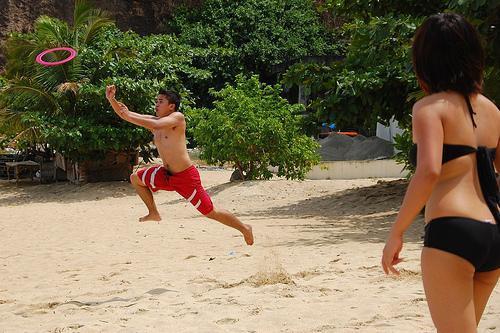How many people can be seen?
Give a very brief answer. 2. 